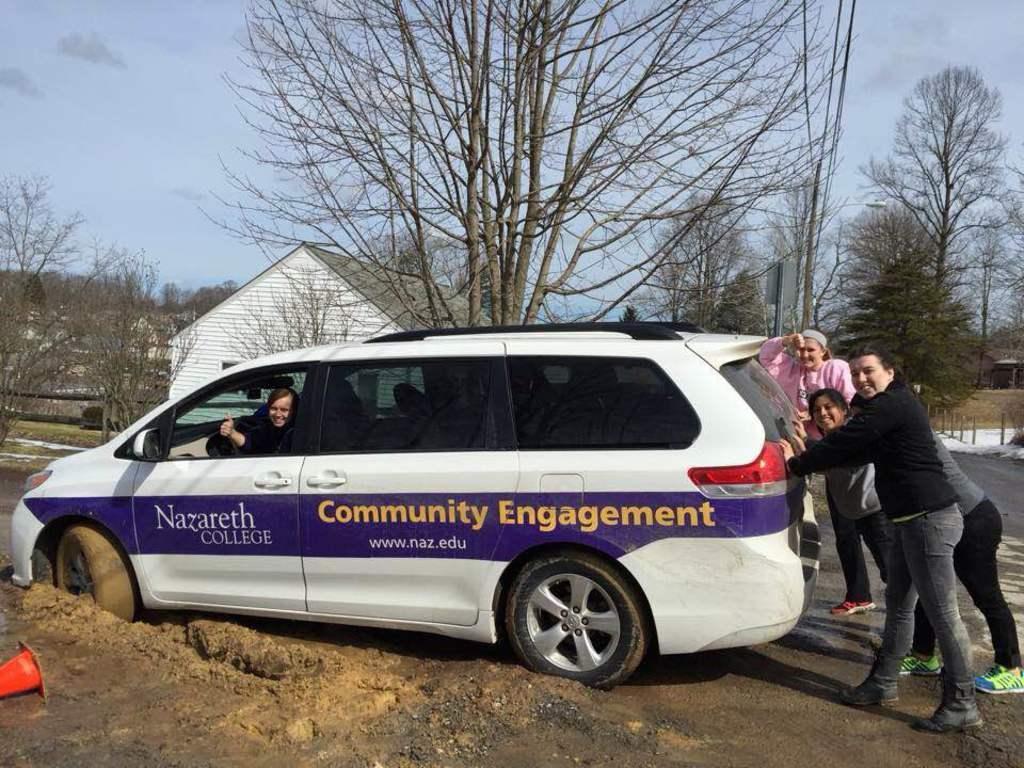Describe this image in one or two sentences. In this picture few persons are trying to push the car, and a woman is seated in the car, in the background we can see building and couple of trees. 